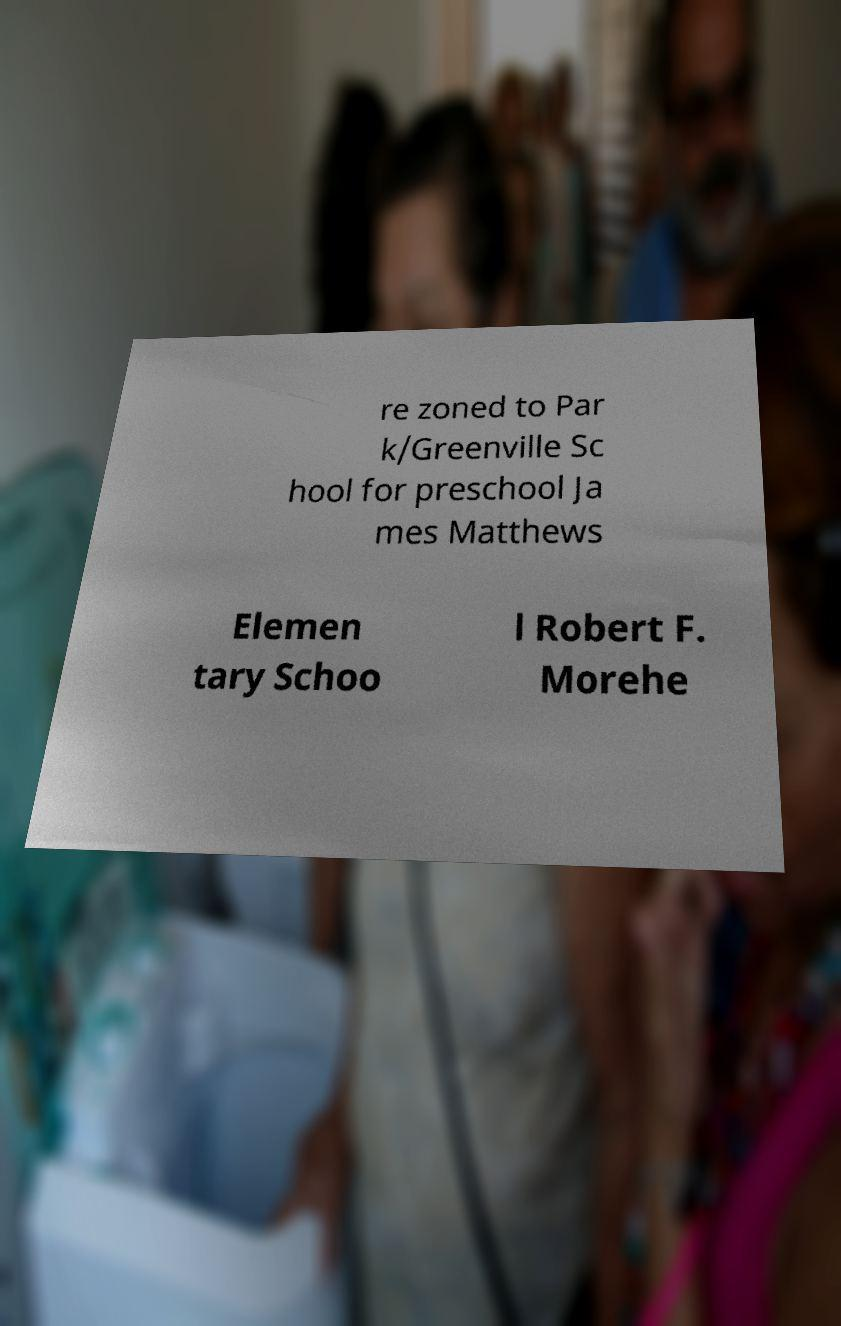I need the written content from this picture converted into text. Can you do that? re zoned to Par k/Greenville Sc hool for preschool Ja mes Matthews Elemen tary Schoo l Robert F. Morehe 